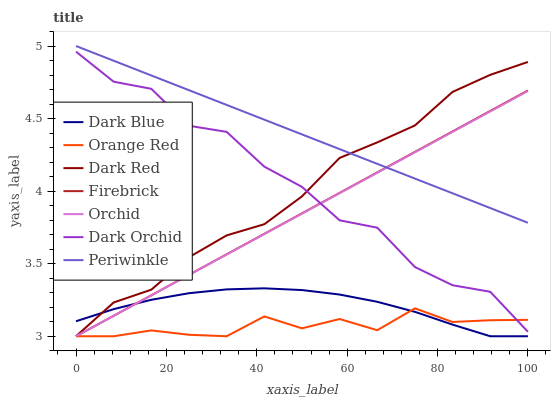Does Orange Red have the minimum area under the curve?
Answer yes or no. Yes. Does Periwinkle have the maximum area under the curve?
Answer yes or no. Yes. Does Firebrick have the minimum area under the curve?
Answer yes or no. No. Does Firebrick have the maximum area under the curve?
Answer yes or no. No. Is Orchid the smoothest?
Answer yes or no. Yes. Is Dark Orchid the roughest?
Answer yes or no. Yes. Is Firebrick the smoothest?
Answer yes or no. No. Is Firebrick the roughest?
Answer yes or no. No. Does Dark Red have the lowest value?
Answer yes or no. Yes. Does Dark Orchid have the lowest value?
Answer yes or no. No. Does Periwinkle have the highest value?
Answer yes or no. Yes. Does Firebrick have the highest value?
Answer yes or no. No. Is Dark Orchid less than Periwinkle?
Answer yes or no. Yes. Is Dark Orchid greater than Dark Blue?
Answer yes or no. Yes. Does Dark Blue intersect Orchid?
Answer yes or no. Yes. Is Dark Blue less than Orchid?
Answer yes or no. No. Is Dark Blue greater than Orchid?
Answer yes or no. No. Does Dark Orchid intersect Periwinkle?
Answer yes or no. No. 